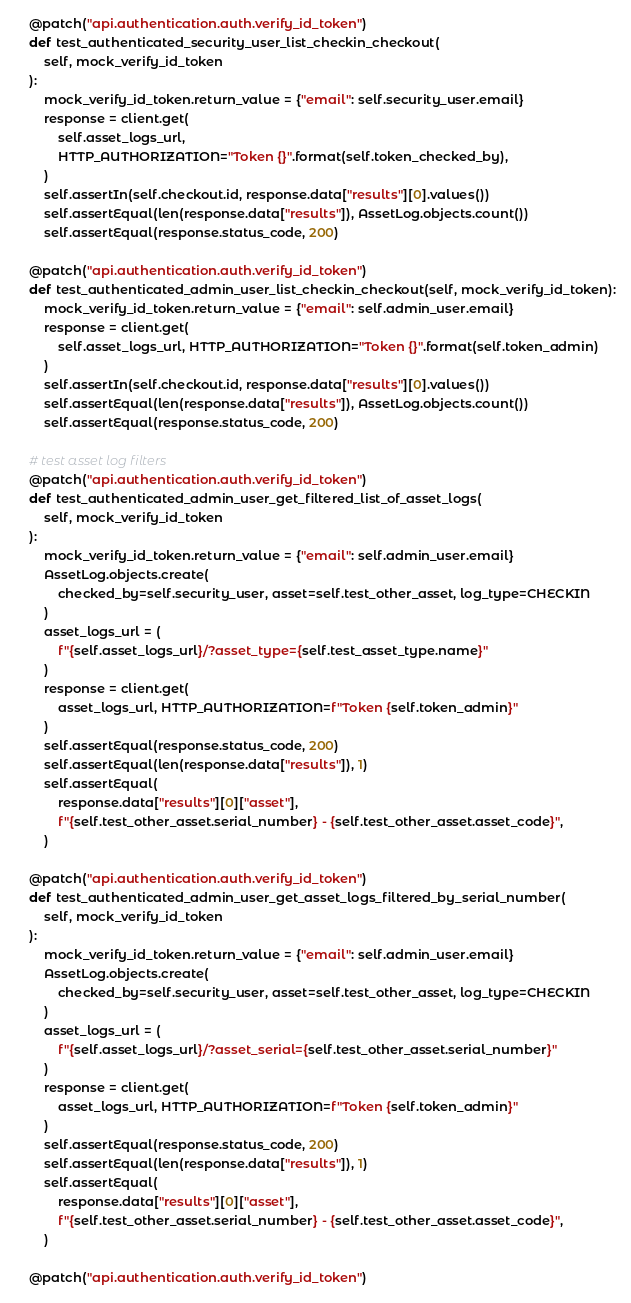Convert code to text. <code><loc_0><loc_0><loc_500><loc_500><_Python_>
    @patch("api.authentication.auth.verify_id_token")
    def test_authenticated_security_user_list_checkin_checkout(
        self, mock_verify_id_token
    ):
        mock_verify_id_token.return_value = {"email": self.security_user.email}
        response = client.get(
            self.asset_logs_url,
            HTTP_AUTHORIZATION="Token {}".format(self.token_checked_by),
        )
        self.assertIn(self.checkout.id, response.data["results"][0].values())
        self.assertEqual(len(response.data["results"]), AssetLog.objects.count())
        self.assertEqual(response.status_code, 200)

    @patch("api.authentication.auth.verify_id_token")
    def test_authenticated_admin_user_list_checkin_checkout(self, mock_verify_id_token):
        mock_verify_id_token.return_value = {"email": self.admin_user.email}
        response = client.get(
            self.asset_logs_url, HTTP_AUTHORIZATION="Token {}".format(self.token_admin)
        )
        self.assertIn(self.checkout.id, response.data["results"][0].values())
        self.assertEqual(len(response.data["results"]), AssetLog.objects.count())
        self.assertEqual(response.status_code, 200)

    # test asset log filters
    @patch("api.authentication.auth.verify_id_token")
    def test_authenticated_admin_user_get_filtered_list_of_asset_logs(
        self, mock_verify_id_token
    ):
        mock_verify_id_token.return_value = {"email": self.admin_user.email}
        AssetLog.objects.create(
            checked_by=self.security_user, asset=self.test_other_asset, log_type=CHECKIN
        )
        asset_logs_url = (
            f"{self.asset_logs_url}/?asset_type={self.test_asset_type.name}"
        )
        response = client.get(
            asset_logs_url, HTTP_AUTHORIZATION=f"Token {self.token_admin}"
        )
        self.assertEqual(response.status_code, 200)
        self.assertEqual(len(response.data["results"]), 1)
        self.assertEqual(
            response.data["results"][0]["asset"],
            f"{self.test_other_asset.serial_number} - {self.test_other_asset.asset_code}",
        )

    @patch("api.authentication.auth.verify_id_token")
    def test_authenticated_admin_user_get_asset_logs_filtered_by_serial_number(
        self, mock_verify_id_token
    ):
        mock_verify_id_token.return_value = {"email": self.admin_user.email}
        AssetLog.objects.create(
            checked_by=self.security_user, asset=self.test_other_asset, log_type=CHECKIN
        )
        asset_logs_url = (
            f"{self.asset_logs_url}/?asset_serial={self.test_other_asset.serial_number}"
        )
        response = client.get(
            asset_logs_url, HTTP_AUTHORIZATION=f"Token {self.token_admin}"
        )
        self.assertEqual(response.status_code, 200)
        self.assertEqual(len(response.data["results"]), 1)
        self.assertEqual(
            response.data["results"][0]["asset"],
            f"{self.test_other_asset.serial_number} - {self.test_other_asset.asset_code}",
        )

    @patch("api.authentication.auth.verify_id_token")</code> 